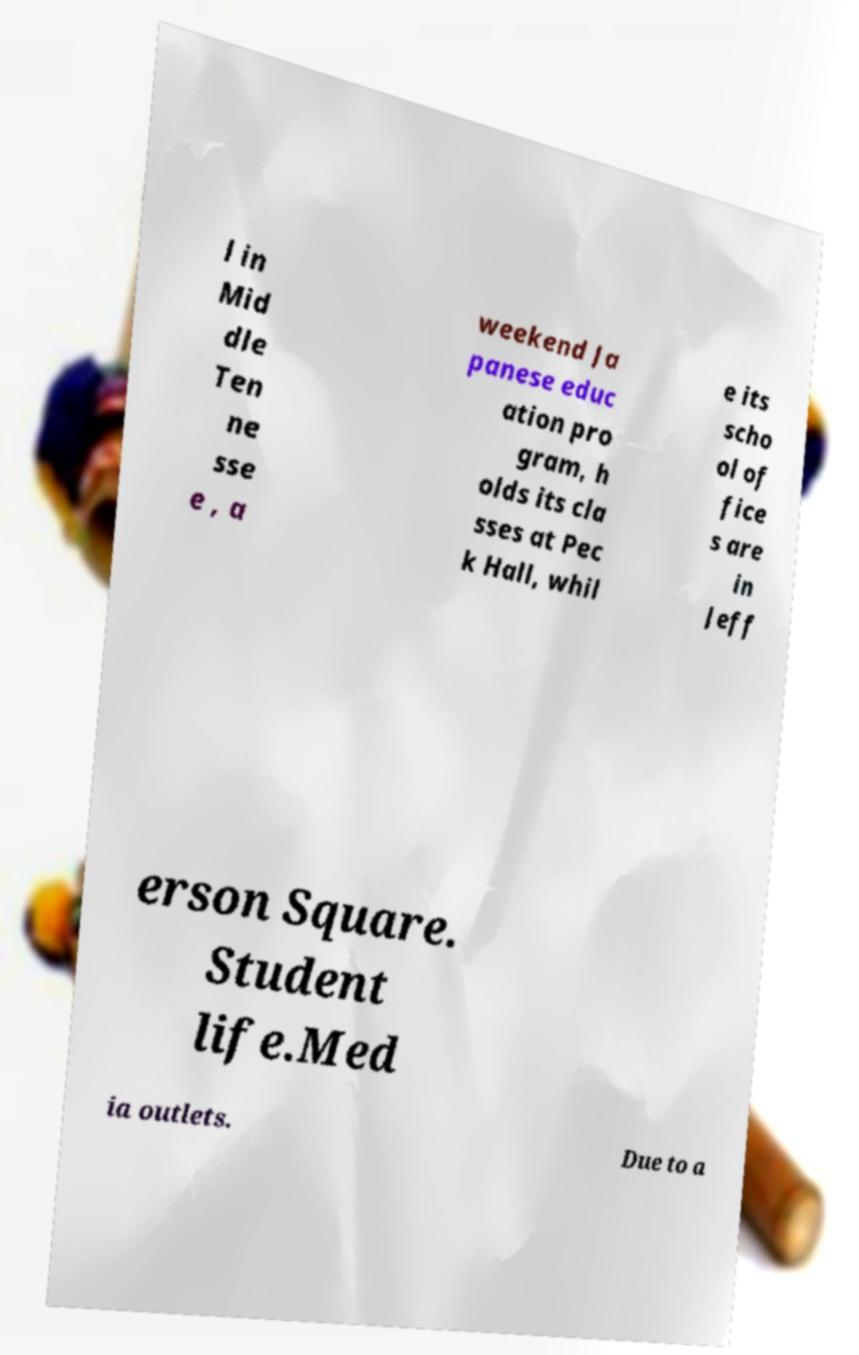Please read and relay the text visible in this image. What does it say? l in Mid dle Ten ne sse e , a weekend Ja panese educ ation pro gram, h olds its cla sses at Pec k Hall, whil e its scho ol of fice s are in Jeff erson Square. Student life.Med ia outlets. Due to a 